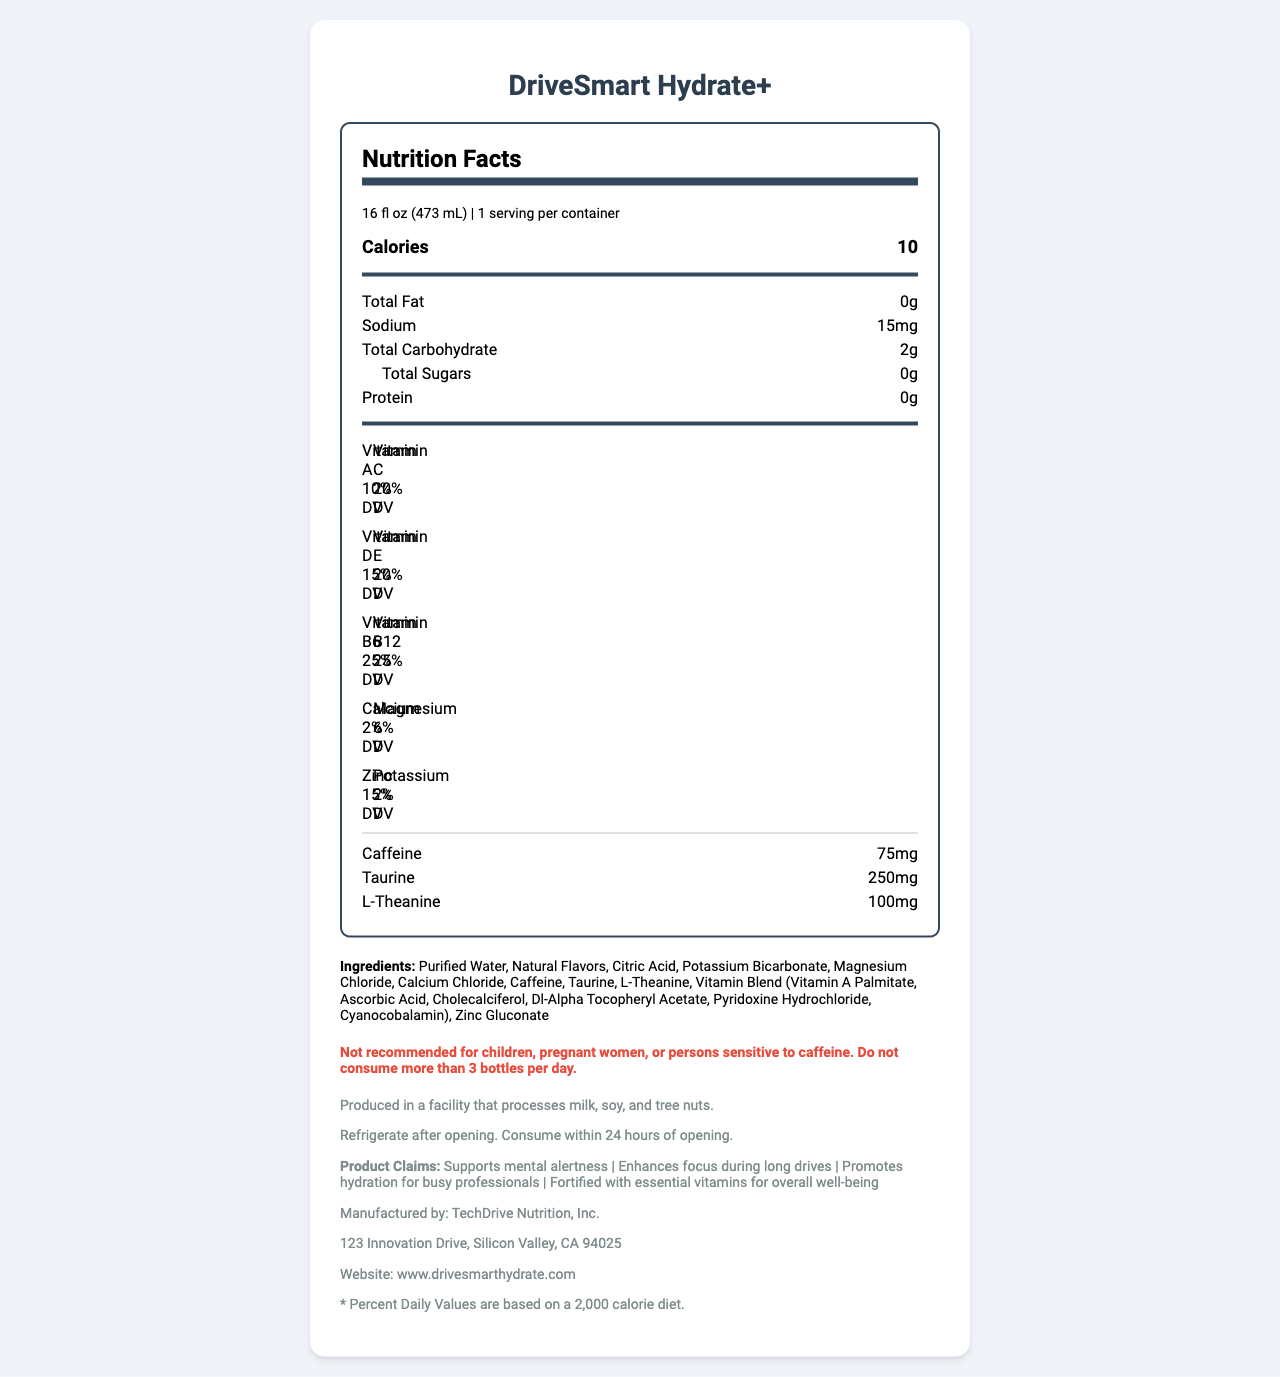what is the serving size of DriveSmart Hydrate+? The serving size is clearly stated at the beginning of the nutrition facts section as "16 fl oz (473 mL)".
Answer: 16 fl oz (473 mL) how many calories are in one serving? The calories per serving are listed prominently in the nutrition facts section as "Calories 10".
Answer: 10 what is the amount of caffeine in one bottle? Under the nutrition facts, caffeine is listed with the amount of "75 mg".
Answer: 75 mg which vitamins have a daily value percentage of 25%? In the vitamins section, both Vitamin B6 and Vitamin B12 are listed with "25% DV".
Answer: Vitamin B6 and Vitamin B12 what ingredients are listed after purified water? The ingredients listed after purified water are all subsequent items in the ingredients list.
Answer: Natural Flavors, Citric Acid, Potassium Bicarbonate, Magnesium Chloride, Calcium Chloride, Caffeine, Taurine, L-Theanine, Vitamin Blend (Vitamin A Palmitate, Ascorbic Acid, Cholecalciferol, Dl-Alpha Tocopheryl Acetate, Pyridoxine Hydrochloride, Cyanocobalamin), Zinc Gluconate what is the main claim of DriveSmart Hydrate+? The product claims section lists multiple claims, with "Supports mental alertness" and "Enhances focus during long drives" appearing first, suggesting their importance.
Answer: Supports mental alertness and enhances focus during long drives how much sodium is in one bottle? Sodium content is listed under the nutrition facts as "15 mg".
Answer: 15 mg what is the total carbohydrate content? The total carbohydrate content is listed under the nutrition facts as "2 g".
Answer: 2 g what percentage of Vitamin C is in DriveSmart Hydrate+? Vitamin C is listed with "20% DV" in the vitamins section.
Answer: 20% DV which of the following is not an ingredient in DriveSmart Hydrate+? A. Magnesium Chloride B. High Fructose Corn Syrup C. Natural Flavors D. Taurine High Fructose Corn Syrup is not listed in the ingredients section of the nutrition label.
Answer: B. High Fructose Corn Syrup which entity manufactures DriveSmart Hydrate+? i. DriveSmart Inc. ii. TechDrive Nutrition, Inc. iii. Tech Support Nutrition iv. DriveTech Nutrition The manufacturer is listed as "TechDrive Nutrition, Inc." under the product information section.
Answer: ii. TechDrive Nutrition, Inc. is DriveSmart Hydrate+ suitable for children? The warning section states, "Not recommended for children, pregnant women, or persons sensitive to caffeine."
Answer: No summarize the main idea of the document. This summary covers the key details about the product, including nutritional content, purpose, and manufacturer.
Answer: The document provides the nutrition facts for DriveSmart Hydrate+, a vitamin-fortified bottled water aimed at on-the-go professionals. It includes details on serving size, calorie content, nutrient percentages, ingredients, warnings, storage instructions, and manufacturer information. The beverage is designed to support mental alertness and enhance focus, promoting hydration while being fortified with essential vitamins. what is the daily value recommendation for magnesium? Magnesium is listed in the vitamins section with "6% DV".
Answer: 6% DV what are the possible allergens mentioned? The allergen information specifies that the product is produced in a facility that processes milk, soy, and tree nuts.
Answer: Milk, soy, and tree nuts how long can DriveSmart Hydrate+ be consumed after opening? The storage instructions advise to refrigerate after opening and consume within 24 hours.
Answer: Within 24 hours of opening what percentage of calcium does one serving of DriveSmart Hydrate+ provide? The vitamins section lists calcium with "2% DV".
Answer: 2% DV how many grams of protein does DriveSmart Hydrate+ contain? The nutrition facts show that the product has "Protein 0 g".
Answer: 0 g are there any added sugars in DriveSmart Hydrate+? The total sugars listed are "0 g", indicating no added sugars.
Answer: No where is the headquarters of TechDrive Nutrition, Inc.? The manufacturer address provided is "123 Innovation Drive, Silicon Valley, CA 94025".
Answer: 123 Innovation Drive, Silicon Valley, CA 94025 when should pregnant women consume DriveSmart Hydrate+? The warning section states that it is "Not recommended for children, pregnant women, or persons sensitive to caffeine."
Answer: Not recommended for pregnant women what year did TechDrive Nutrition, Inc. buy DriveSmart Hydrate+? The document does not provide any information about the purchase year of DriveSmart Hydrate+.
Answer: Cannot be determined 